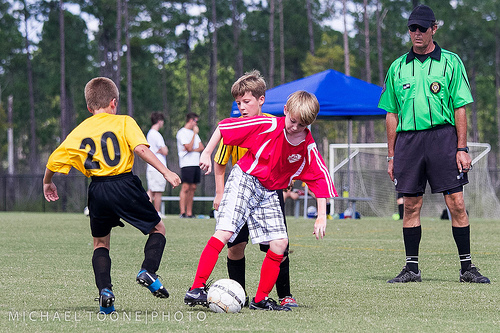<image>
Can you confirm if the boy is to the left of the tent? Yes. From this viewpoint, the boy is positioned to the left side relative to the tent. Where is the boy in relation to the ball? Is it behind the ball? Yes. From this viewpoint, the boy is positioned behind the ball, with the ball partially or fully occluding the boy. Is the boy in the grass? No. The boy is not contained within the grass. These objects have a different spatial relationship. 